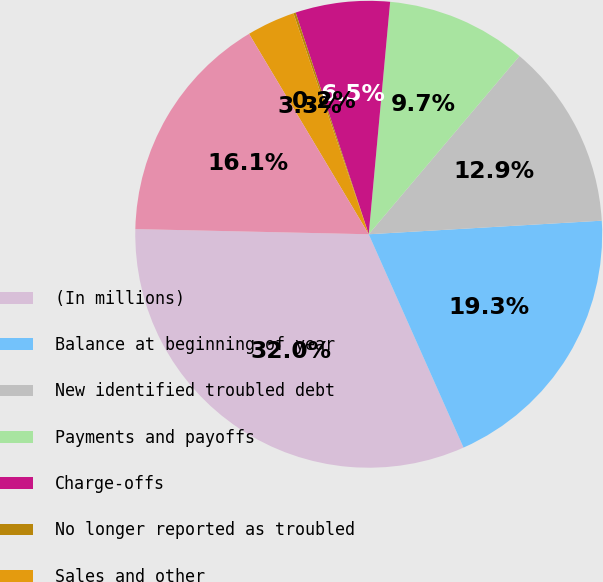Convert chart. <chart><loc_0><loc_0><loc_500><loc_500><pie_chart><fcel>(In millions)<fcel>Balance at beginning of year<fcel>New identified troubled debt<fcel>Payments and payoffs<fcel>Charge-offs<fcel>No longer reported as troubled<fcel>Sales and other<fcel>Balance at end of year<nl><fcel>32.01%<fcel>19.27%<fcel>12.9%<fcel>9.71%<fcel>6.53%<fcel>0.16%<fcel>3.34%<fcel>16.08%<nl></chart> 